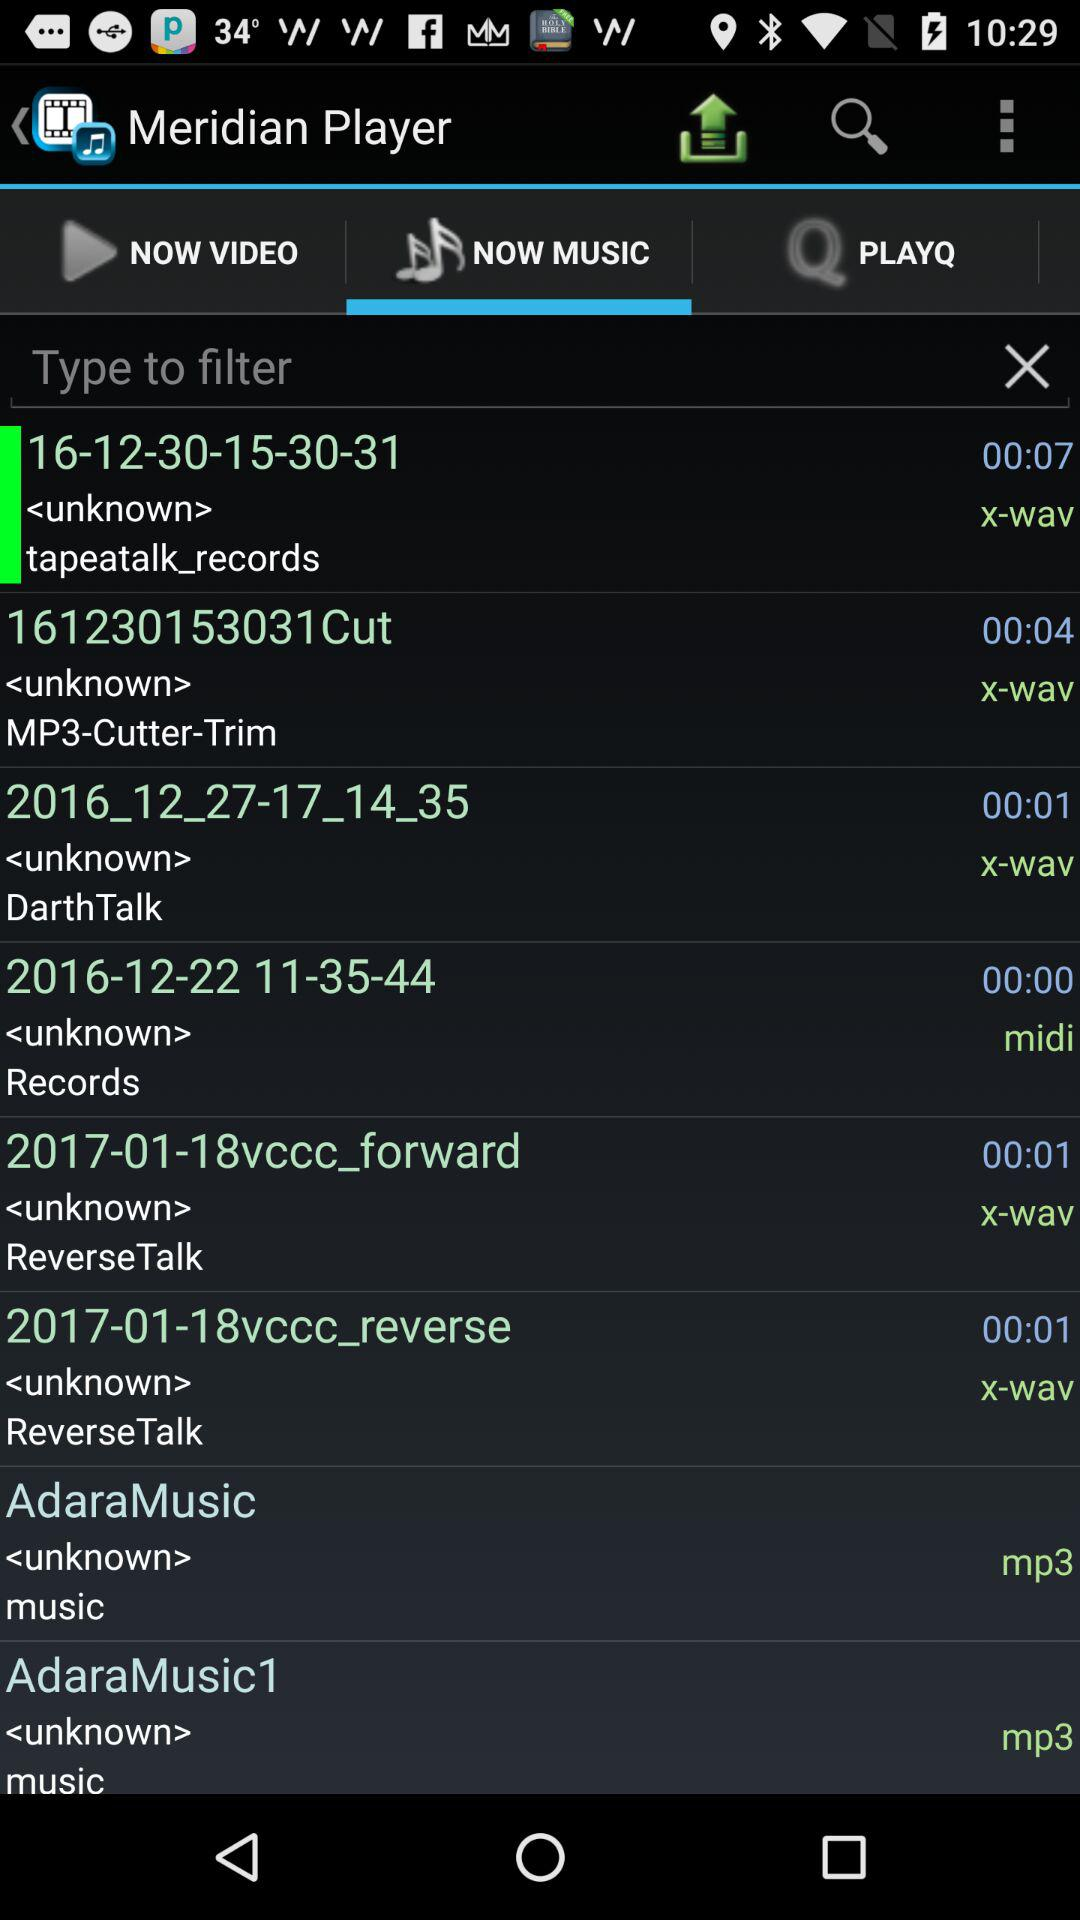What is the duration of "2016-12-22 11-35-44"? The duration of "2016-12-22 11-35-44" is 0 minutes and 0 seconds. 